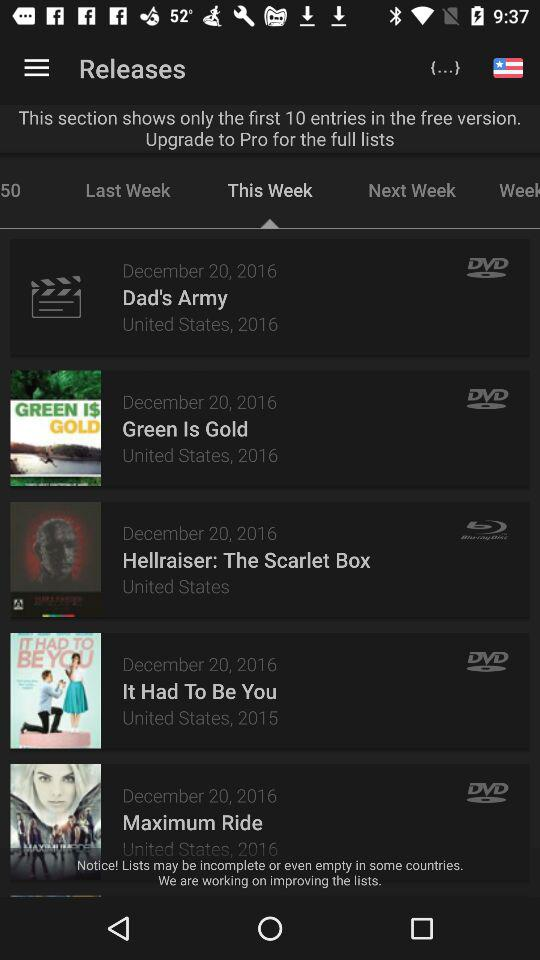What's the release date of "Green Is Gold"? The release date is December 20, 2016. 